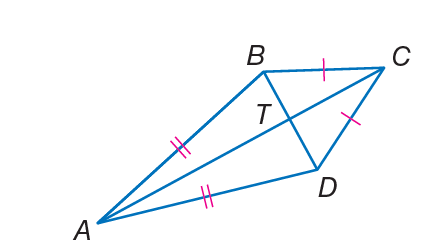How could the properties of a kite be used to find the lengths of sides AD and DC if side AB was known to be 5 units and side BC was known to be 3 units? In a kite, the two pairs of adjacent sides are equal. Given that AB is 5 units, then AD would also be 5 units, because they are adjacent sides in the kite. Since BC is 3 units, then CD would also be 3 units for the same reason. Therefore, using the properties of a kite, we can conclude that side AD is 5 units and side DC is 3 units long. 